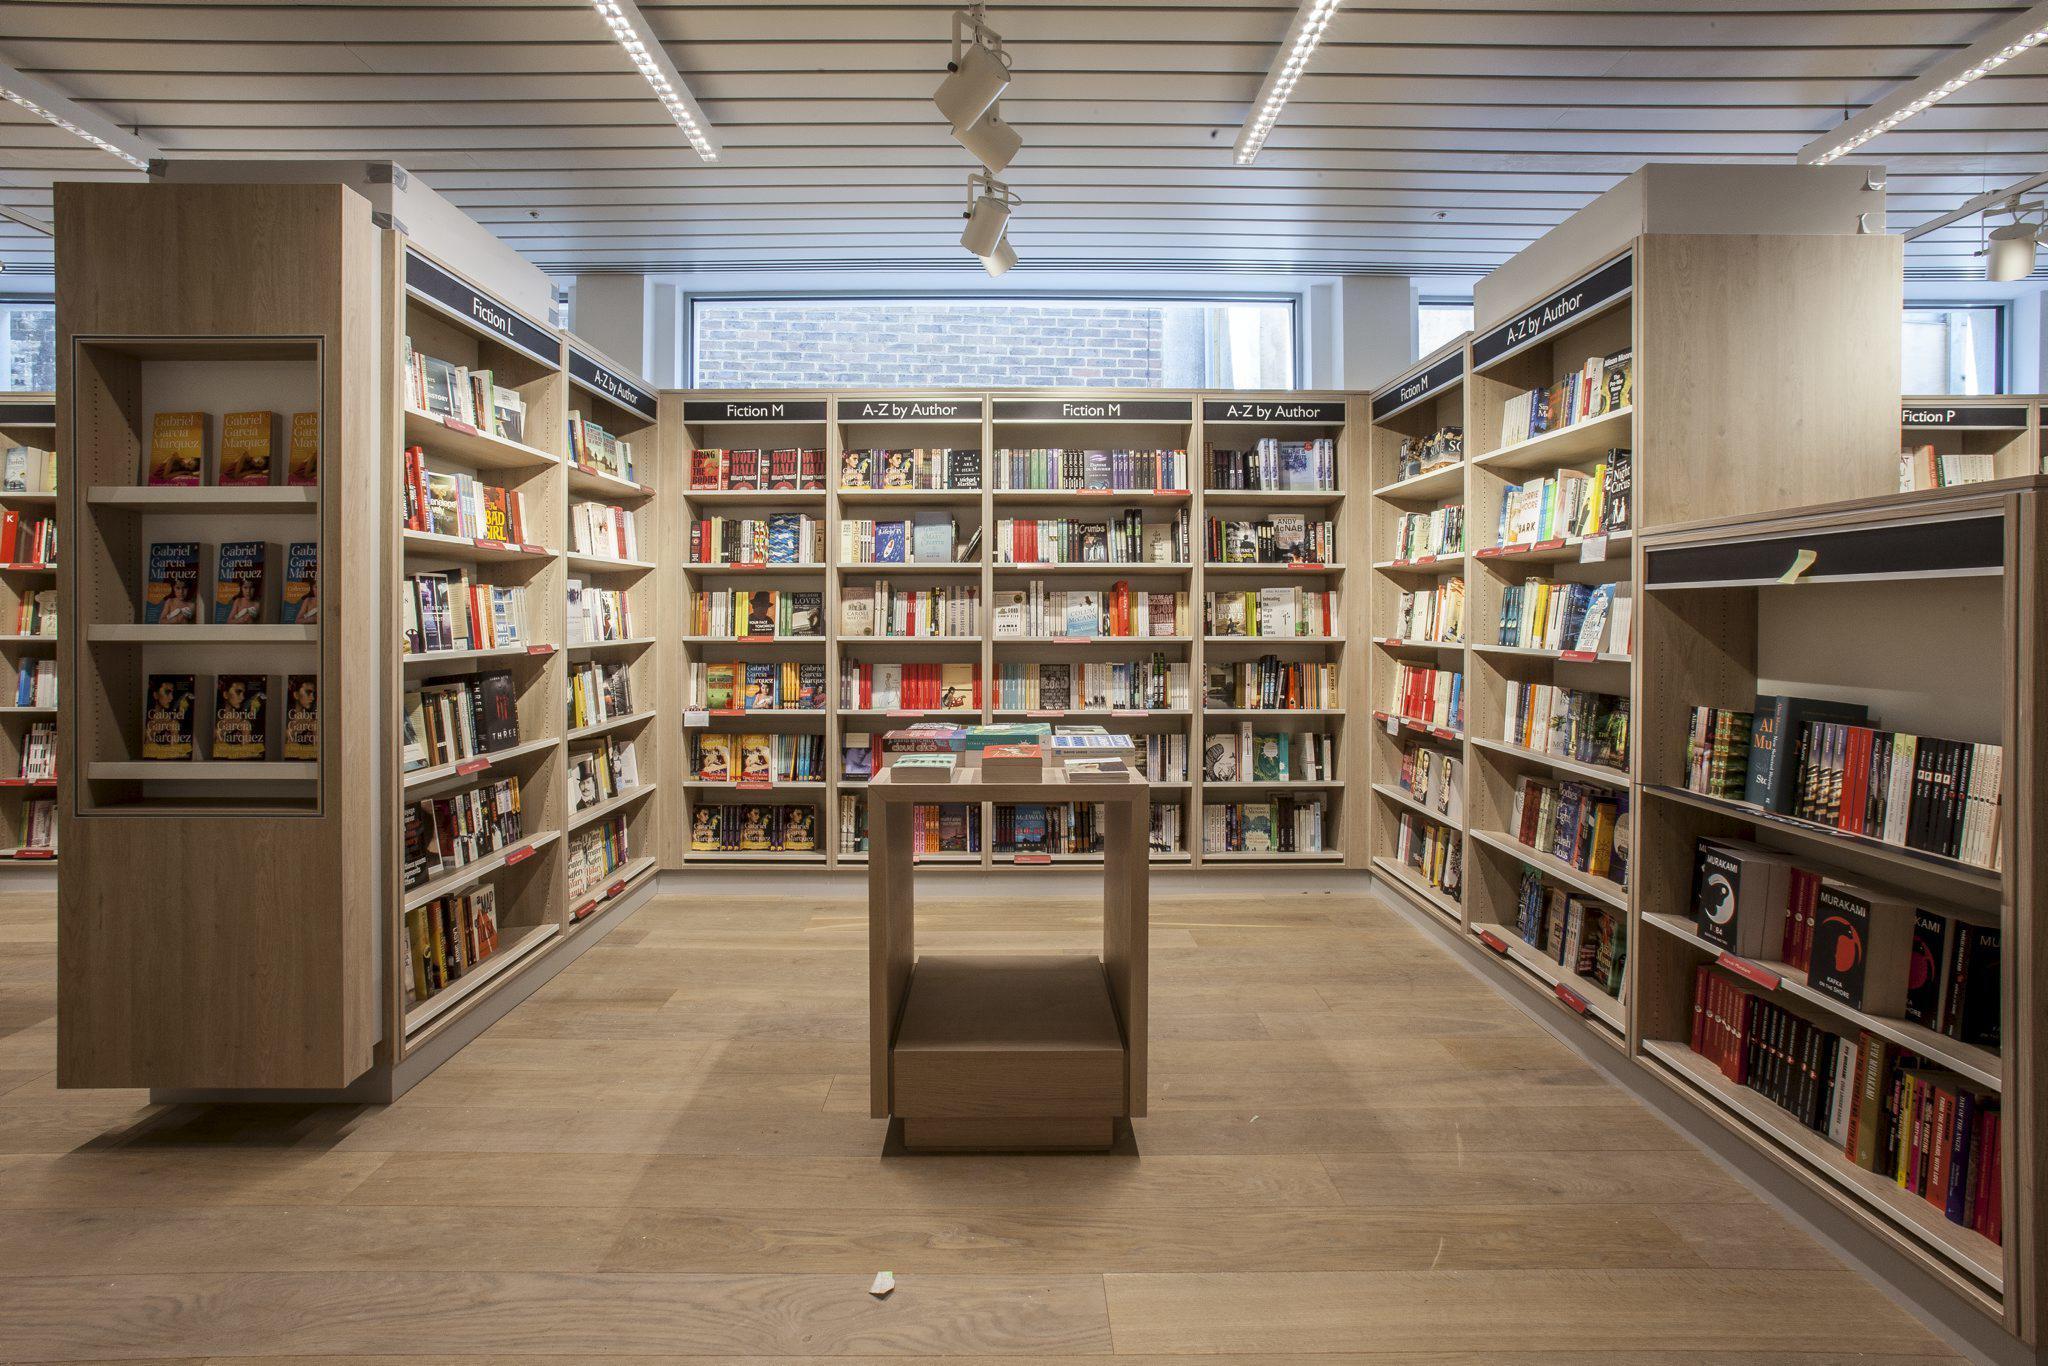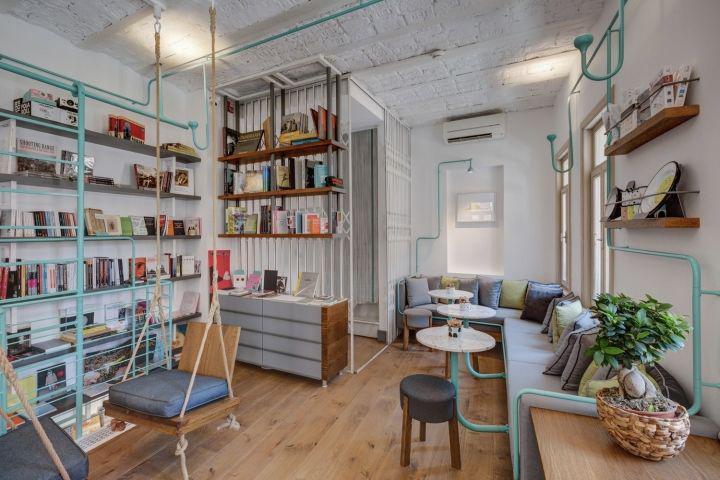The first image is the image on the left, the second image is the image on the right. Given the left and right images, does the statement "There is at least one person in the image on the left." hold true? Answer yes or no. No. The first image is the image on the left, the second image is the image on the right. Assess this claim about the two images: "One image shows a seating area in a book store.". Correct or not? Answer yes or no. Yes. 